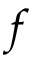Convert formula to latex. <formula><loc_0><loc_0><loc_500><loc_500>f</formula> 